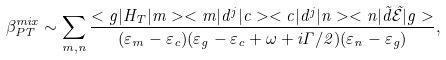Convert formula to latex. <formula><loc_0><loc_0><loc_500><loc_500>\beta ^ { m i x } _ { P T } \sim \sum _ { m , n } \frac { < g | H _ { T } | m > < m | d ^ { j } | c > < c | d ^ { j } | n > < n | \vec { d } \vec { \mathcal { E } } | g > } { ( \varepsilon _ { m } - \varepsilon _ { c } ) ( \varepsilon _ { g } - \varepsilon _ { c } + \omega + i { \Gamma } / { 2 } ) ( \varepsilon _ { n } - \varepsilon _ { g } ) } ,</formula> 